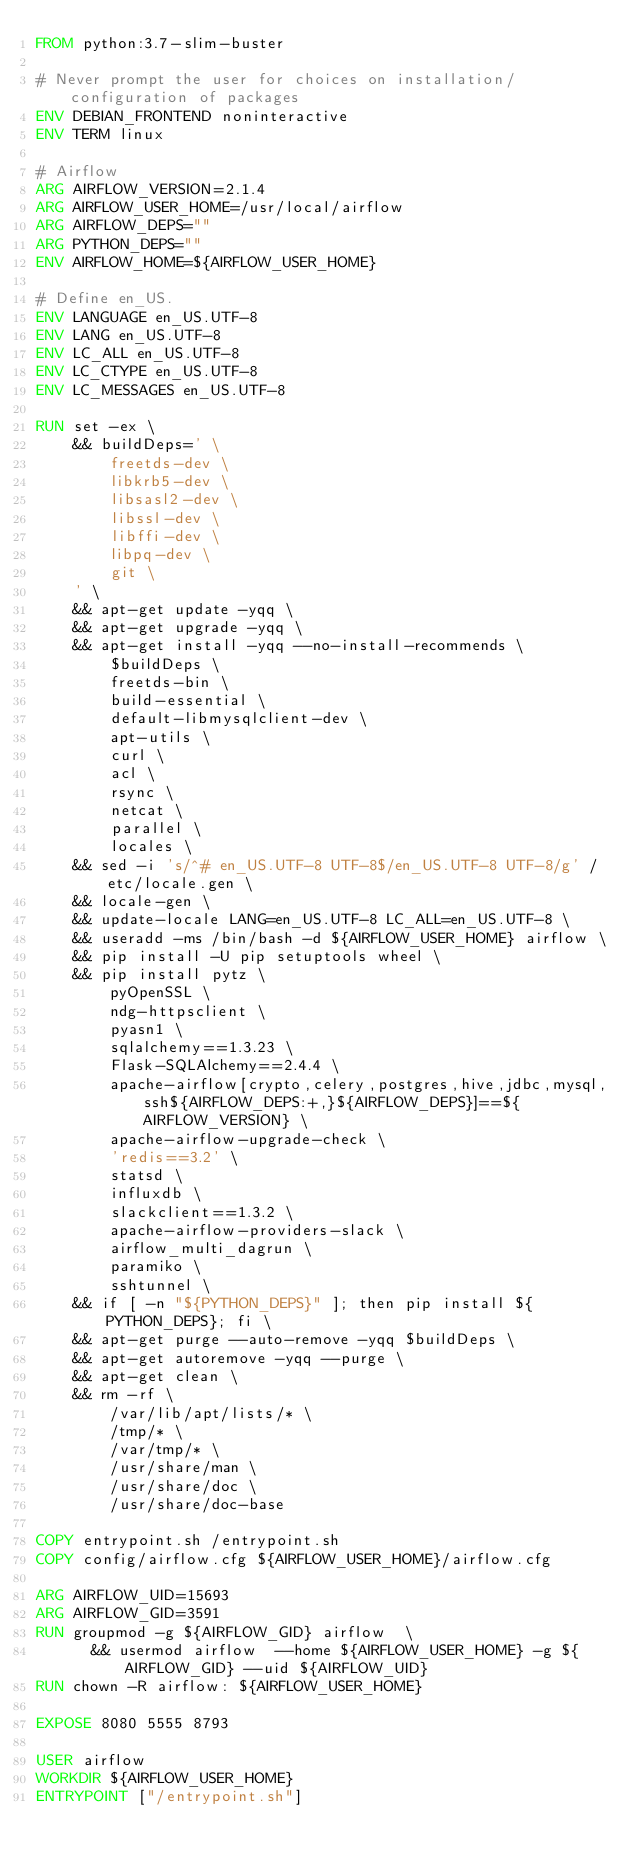<code> <loc_0><loc_0><loc_500><loc_500><_Dockerfile_>FROM python:3.7-slim-buster

# Never prompt the user for choices on installation/configuration of packages
ENV DEBIAN_FRONTEND noninteractive
ENV TERM linux

# Airflow
ARG AIRFLOW_VERSION=2.1.4
ARG AIRFLOW_USER_HOME=/usr/local/airflow
ARG AIRFLOW_DEPS=""
ARG PYTHON_DEPS=""
ENV AIRFLOW_HOME=${AIRFLOW_USER_HOME}

# Define en_US.
ENV LANGUAGE en_US.UTF-8
ENV LANG en_US.UTF-8
ENV LC_ALL en_US.UTF-8
ENV LC_CTYPE en_US.UTF-8
ENV LC_MESSAGES en_US.UTF-8

RUN set -ex \
    && buildDeps=' \
        freetds-dev \
        libkrb5-dev \
        libsasl2-dev \
        libssl-dev \
        libffi-dev \
        libpq-dev \
        git \
    ' \
    && apt-get update -yqq \
    && apt-get upgrade -yqq \
    && apt-get install -yqq --no-install-recommends \
        $buildDeps \
        freetds-bin \
        build-essential \
        default-libmysqlclient-dev \
        apt-utils \
        curl \
        acl \
        rsync \
        netcat \
        parallel \
        locales \
    && sed -i 's/^# en_US.UTF-8 UTF-8$/en_US.UTF-8 UTF-8/g' /etc/locale.gen \
    && locale-gen \
    && update-locale LANG=en_US.UTF-8 LC_ALL=en_US.UTF-8 \
    && useradd -ms /bin/bash -d ${AIRFLOW_USER_HOME} airflow \
    && pip install -U pip setuptools wheel \
    && pip install pytz \
        pyOpenSSL \
        ndg-httpsclient \
        pyasn1 \
        sqlalchemy==1.3.23 \
        Flask-SQLAlchemy==2.4.4 \
        apache-airflow[crypto,celery,postgres,hive,jdbc,mysql,ssh${AIRFLOW_DEPS:+,}${AIRFLOW_DEPS}]==${AIRFLOW_VERSION} \
        apache-airflow-upgrade-check \
        'redis==3.2' \
        statsd \
        influxdb \
        slackclient==1.3.2 \
        apache-airflow-providers-slack \
        airflow_multi_dagrun \
        paramiko \
        sshtunnel \
    && if [ -n "${PYTHON_DEPS}" ]; then pip install ${PYTHON_DEPS}; fi \
    && apt-get purge --auto-remove -yqq $buildDeps \
    && apt-get autoremove -yqq --purge \
    && apt-get clean \
    && rm -rf \
        /var/lib/apt/lists/* \
        /tmp/* \
        /var/tmp/* \
        /usr/share/man \
        /usr/share/doc \
        /usr/share/doc-base

COPY entrypoint.sh /entrypoint.sh
COPY config/airflow.cfg ${AIRFLOW_USER_HOME}/airflow.cfg

ARG AIRFLOW_UID=15693
ARG AIRFLOW_GID=3591
RUN groupmod -g ${AIRFLOW_GID} airflow  \
      && usermod airflow  --home ${AIRFLOW_USER_HOME} -g ${AIRFLOW_GID} --uid ${AIRFLOW_UID}
RUN chown -R airflow: ${AIRFLOW_USER_HOME}

EXPOSE 8080 5555 8793

USER airflow
WORKDIR ${AIRFLOW_USER_HOME}
ENTRYPOINT ["/entrypoint.sh"]

</code> 